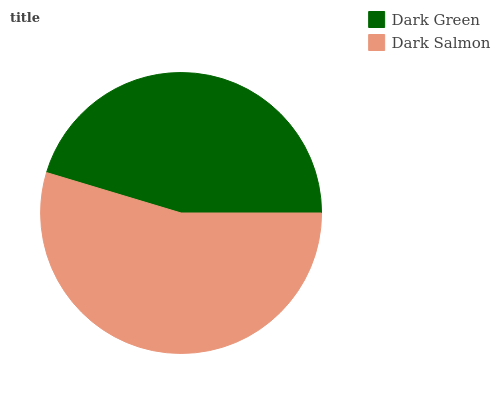Is Dark Green the minimum?
Answer yes or no. Yes. Is Dark Salmon the maximum?
Answer yes or no. Yes. Is Dark Salmon the minimum?
Answer yes or no. No. Is Dark Salmon greater than Dark Green?
Answer yes or no. Yes. Is Dark Green less than Dark Salmon?
Answer yes or no. Yes. Is Dark Green greater than Dark Salmon?
Answer yes or no. No. Is Dark Salmon less than Dark Green?
Answer yes or no. No. Is Dark Salmon the high median?
Answer yes or no. Yes. Is Dark Green the low median?
Answer yes or no. Yes. Is Dark Green the high median?
Answer yes or no. No. Is Dark Salmon the low median?
Answer yes or no. No. 